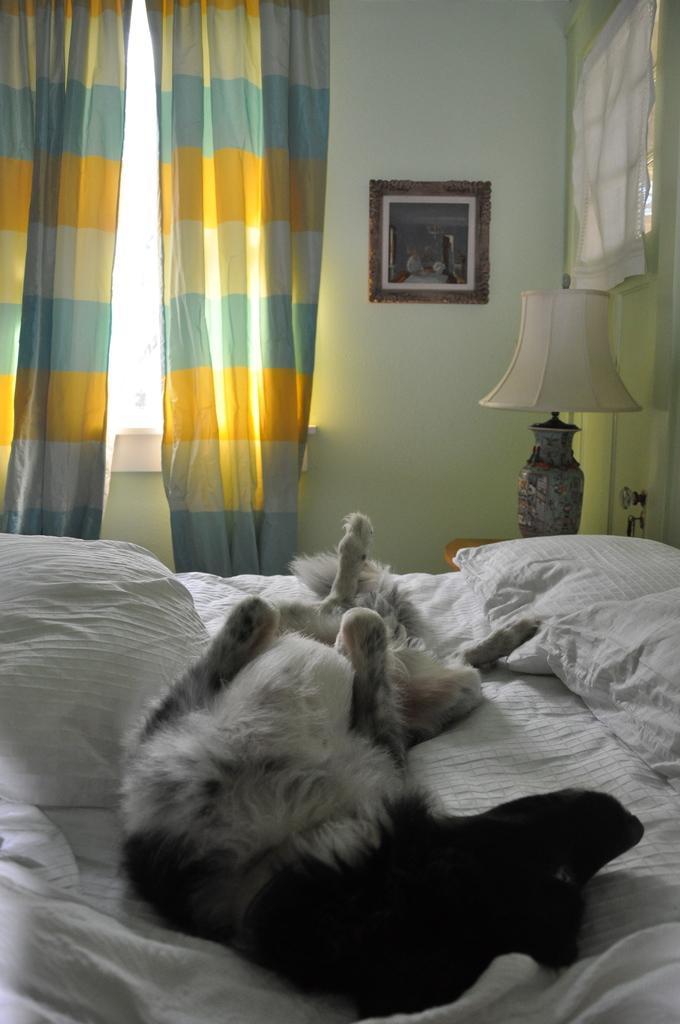What animals are on the bed in the image? There are dogs on the bed. What object can be seen on a table in the image? There is a lamp on a table. What is hanging on the wall in the background of the image? There is a frame on the wall in the background. What type of window treatment is present in the image? There are curtains on a window in the background. Can you see any dogs swimming in the image? There are no dogs swimming in the image; the dogs are on the bed. What type of straw is used to decorate the frame in the image? There is no straw present in the image; it features a frame on the wall in the background. 